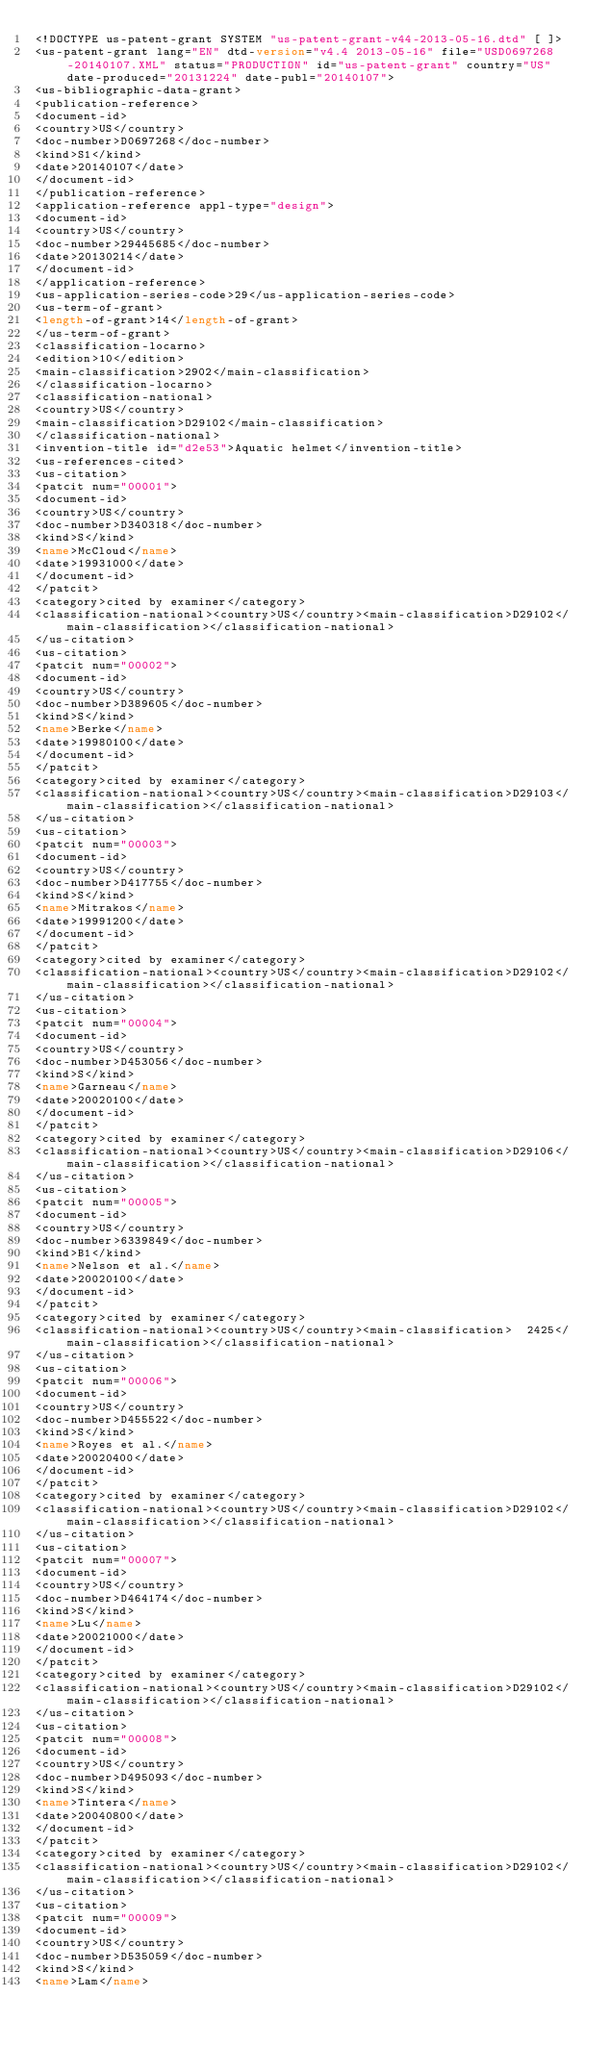Convert code to text. <code><loc_0><loc_0><loc_500><loc_500><_XML_><!DOCTYPE us-patent-grant SYSTEM "us-patent-grant-v44-2013-05-16.dtd" [ ]>
<us-patent-grant lang="EN" dtd-version="v4.4 2013-05-16" file="USD0697268-20140107.XML" status="PRODUCTION" id="us-patent-grant" country="US" date-produced="20131224" date-publ="20140107">
<us-bibliographic-data-grant>
<publication-reference>
<document-id>
<country>US</country>
<doc-number>D0697268</doc-number>
<kind>S1</kind>
<date>20140107</date>
</document-id>
</publication-reference>
<application-reference appl-type="design">
<document-id>
<country>US</country>
<doc-number>29445685</doc-number>
<date>20130214</date>
</document-id>
</application-reference>
<us-application-series-code>29</us-application-series-code>
<us-term-of-grant>
<length-of-grant>14</length-of-grant>
</us-term-of-grant>
<classification-locarno>
<edition>10</edition>
<main-classification>2902</main-classification>
</classification-locarno>
<classification-national>
<country>US</country>
<main-classification>D29102</main-classification>
</classification-national>
<invention-title id="d2e53">Aquatic helmet</invention-title>
<us-references-cited>
<us-citation>
<patcit num="00001">
<document-id>
<country>US</country>
<doc-number>D340318</doc-number>
<kind>S</kind>
<name>McCloud</name>
<date>19931000</date>
</document-id>
</patcit>
<category>cited by examiner</category>
<classification-national><country>US</country><main-classification>D29102</main-classification></classification-national>
</us-citation>
<us-citation>
<patcit num="00002">
<document-id>
<country>US</country>
<doc-number>D389605</doc-number>
<kind>S</kind>
<name>Berke</name>
<date>19980100</date>
</document-id>
</patcit>
<category>cited by examiner</category>
<classification-national><country>US</country><main-classification>D29103</main-classification></classification-national>
</us-citation>
<us-citation>
<patcit num="00003">
<document-id>
<country>US</country>
<doc-number>D417755</doc-number>
<kind>S</kind>
<name>Mitrakos</name>
<date>19991200</date>
</document-id>
</patcit>
<category>cited by examiner</category>
<classification-national><country>US</country><main-classification>D29102</main-classification></classification-national>
</us-citation>
<us-citation>
<patcit num="00004">
<document-id>
<country>US</country>
<doc-number>D453056</doc-number>
<kind>S</kind>
<name>Garneau</name>
<date>20020100</date>
</document-id>
</patcit>
<category>cited by examiner</category>
<classification-national><country>US</country><main-classification>D29106</main-classification></classification-national>
</us-citation>
<us-citation>
<patcit num="00005">
<document-id>
<country>US</country>
<doc-number>6339849</doc-number>
<kind>B1</kind>
<name>Nelson et al.</name>
<date>20020100</date>
</document-id>
</patcit>
<category>cited by examiner</category>
<classification-national><country>US</country><main-classification>  2425</main-classification></classification-national>
</us-citation>
<us-citation>
<patcit num="00006">
<document-id>
<country>US</country>
<doc-number>D455522</doc-number>
<kind>S</kind>
<name>Royes et al.</name>
<date>20020400</date>
</document-id>
</patcit>
<category>cited by examiner</category>
<classification-national><country>US</country><main-classification>D29102</main-classification></classification-national>
</us-citation>
<us-citation>
<patcit num="00007">
<document-id>
<country>US</country>
<doc-number>D464174</doc-number>
<kind>S</kind>
<name>Lu</name>
<date>20021000</date>
</document-id>
</patcit>
<category>cited by examiner</category>
<classification-national><country>US</country><main-classification>D29102</main-classification></classification-national>
</us-citation>
<us-citation>
<patcit num="00008">
<document-id>
<country>US</country>
<doc-number>D495093</doc-number>
<kind>S</kind>
<name>Tintera</name>
<date>20040800</date>
</document-id>
</patcit>
<category>cited by examiner</category>
<classification-national><country>US</country><main-classification>D29102</main-classification></classification-national>
</us-citation>
<us-citation>
<patcit num="00009">
<document-id>
<country>US</country>
<doc-number>D535059</doc-number>
<kind>S</kind>
<name>Lam</name></code> 